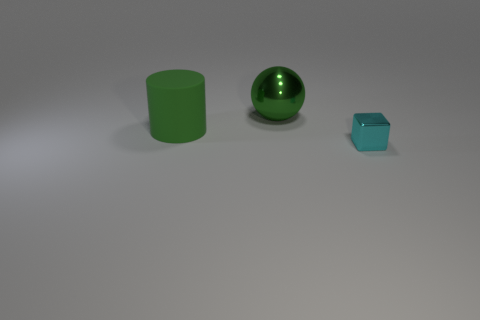Add 3 purple metallic cubes. How many objects exist? 6 Subtract all cylinders. How many objects are left? 2 Add 2 big green matte objects. How many big green matte objects are left? 3 Add 3 large spheres. How many large spheres exist? 4 Subtract 1 cyan blocks. How many objects are left? 2 Subtract all big red cylinders. Subtract all matte objects. How many objects are left? 2 